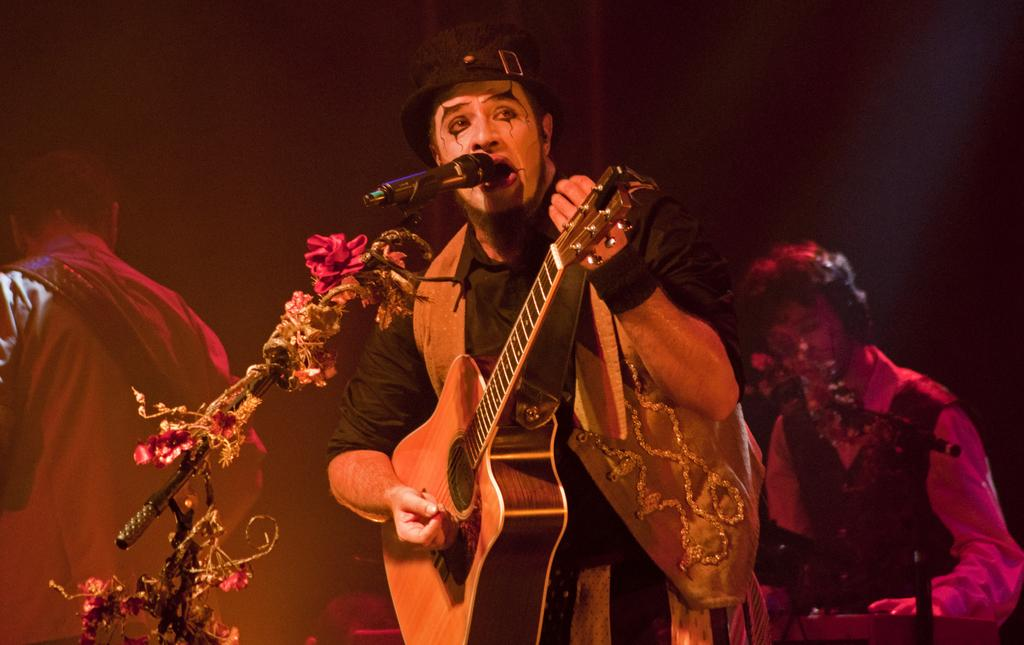How many people are in the image? There are people standing in the image. What is one person holding in the image? One person is holding a guitar. What object is in front of the person holding the guitar? There is a microphone (mic) in front of the person holding the guitar. What type of tooth can be seen in the image? There is no tooth present in the image. Are there any planes visible in the image? There is no mention of planes in the provided facts, so we cannot determine if they are present in the image. 